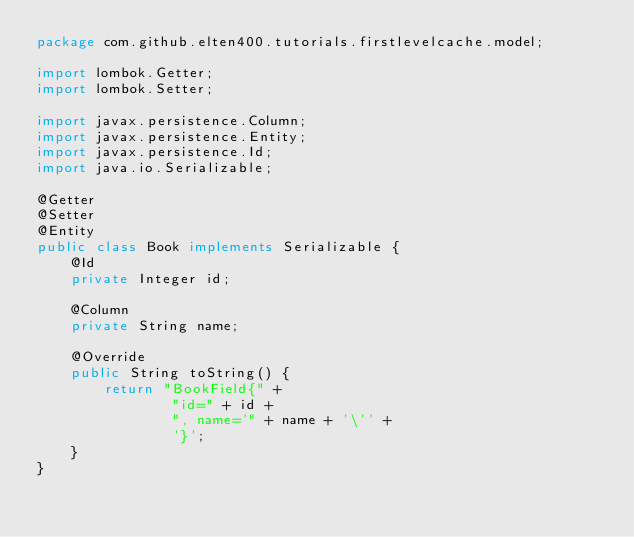Convert code to text. <code><loc_0><loc_0><loc_500><loc_500><_Java_>package com.github.elten400.tutorials.firstlevelcache.model;

import lombok.Getter;
import lombok.Setter;

import javax.persistence.Column;
import javax.persistence.Entity;
import javax.persistence.Id;
import java.io.Serializable;

@Getter
@Setter
@Entity
public class Book implements Serializable {
    @Id
    private Integer id;

    @Column
    private String name;

    @Override
    public String toString() {
        return "BookField{" +
                "id=" + id +
                ", name='" + name + '\'' +
                '}';
    }
}</code> 